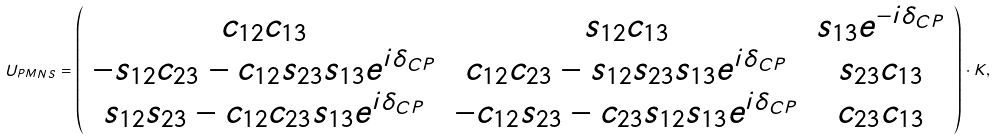<formula> <loc_0><loc_0><loc_500><loc_500>U _ { P M N S } = \left ( \begin{array} { c c c } c _ { 1 2 } c _ { 1 3 } & s _ { 1 2 } c _ { 1 3 } & s _ { 1 3 } e ^ { - i \delta _ { C P } } \\ - s _ { 1 2 } c _ { 2 3 } - c _ { 1 2 } s _ { 2 3 } s _ { 1 3 } e ^ { i \delta _ { C P } } & c _ { 1 2 } c _ { 2 3 } - s _ { 1 2 } s _ { 2 3 } s _ { 1 3 } e ^ { i \delta _ { C P } } & s _ { 2 3 } c _ { 1 3 } \\ s _ { 1 2 } s _ { 2 3 } - c _ { 1 2 } c _ { 2 3 } s _ { 1 3 } e ^ { i \delta _ { C P } } & - c _ { 1 2 } s _ { 2 3 } - c _ { 2 3 } s _ { 1 2 } s _ { 1 3 } e ^ { i \delta _ { C P } } & c _ { 2 3 } c _ { 1 3 } \end{array} \right ) \cdot K ,</formula> 